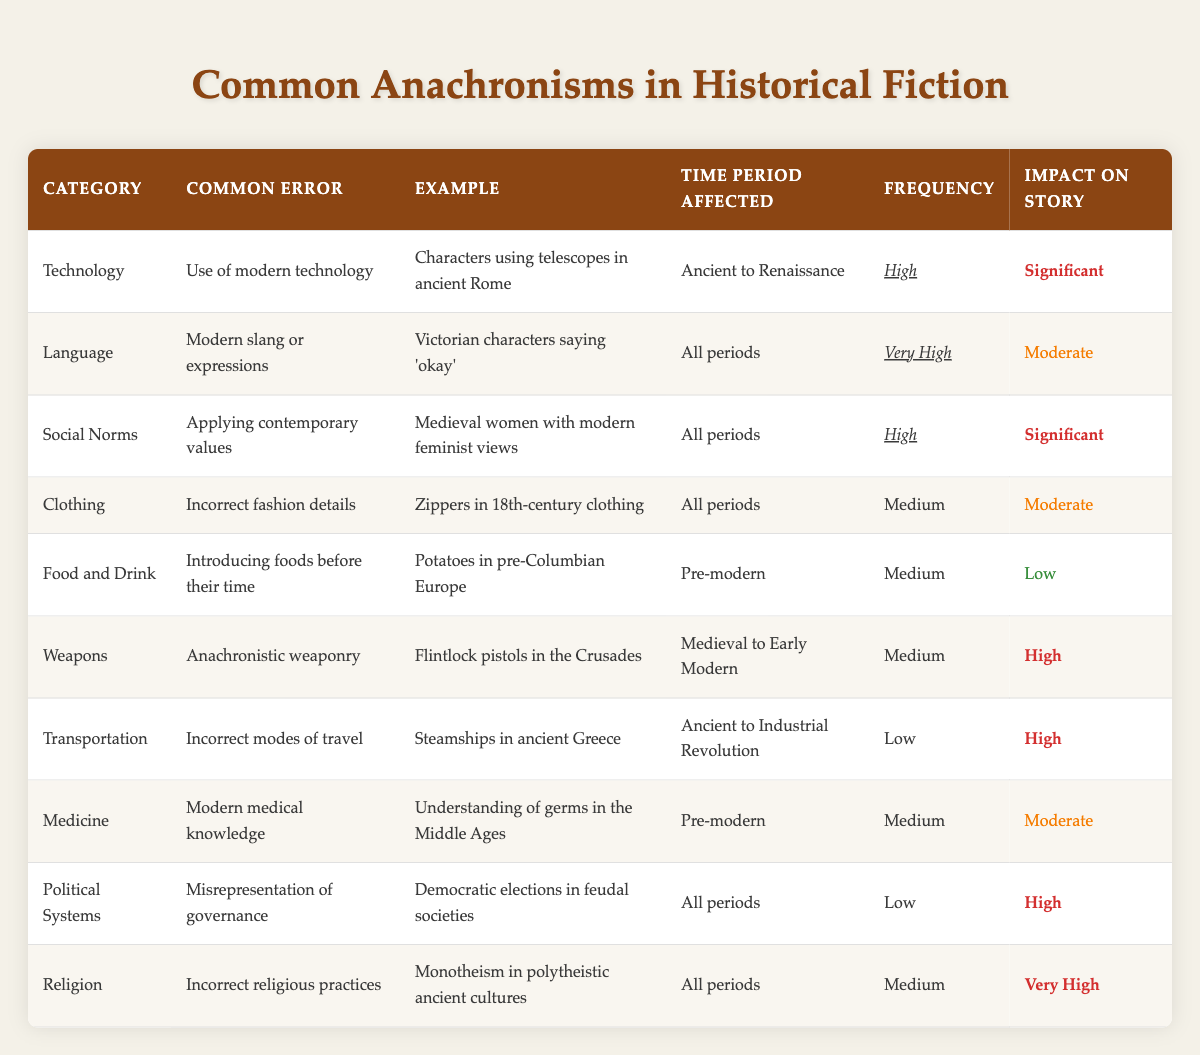What common error in historical fiction has a very high frequency? The table indicates that "Modern slang or expressions" in the Language category has a frequency labeled as "Very High." This is specified in the row under Language where it talks about Victorian characters saying 'okay.'
Answer: Modern slang or expressions Which category has the highest impact on story? The rows for the impact on story indicate that "Incorrect religious practices" and "Use of modern technology" both have a significant impact but "Incorrect religious practices" has a "Very High" label. This shows that it has a higher impact compared to others.
Answer: Incorrect religious practices How many categories have a medium frequency? By examining the frequency column, the categories "Clothing," "Food and Drink," "Weapons," "Medicine," and "Religion" have a frequency labeled as "Medium." There are five such categories listed in the table.
Answer: Five Is there an example of anachronistic weaponry related to the Medieval period? In the Weapons category, the example given is "Flintlock pistols in the Crusades," which clearly shows that it pertains to the Medieval period as the Crusades occurred during that time.
Answer: Yes What is the average impact level of the "Medium" frequency categories? The "Medium" frequency categories list their impacts as "Moderate," and "Low." Therefore, to find the average impact, we count Moderate as a 2 and Low as a 1. The average is (2 + 1) / 2 = 1.5, which aligns with a qualitative understanding that it leans towards moderate as the better descriptor.
Answer: Moderate Which anachronism relates to transportation issues and what is its specific example? The Transportation category lists "Incorrect modes of travel" with the example of "Steamships in ancient Greece." This directly indicates that this is the specific transportation-related anachronism included in the table.
Answer: Steamships in ancient Greece What is the time period affected by applying contemporary values in the Social Norms category? The Social Norms category specifies that applying contemporary values affects "All periods," showing that this issue spans across every historical or fictional timeline.
Answer: All periods Is there a low-frequency anachronism that has a high impact on the story? According to the table, both "Incorrect modes of travel" and "Misrepresentation of governance" fall into low frequency but have a high impact on the story, confirming that there are indeed low-frequency anachronisms with significant impacts.
Answer: Yes 